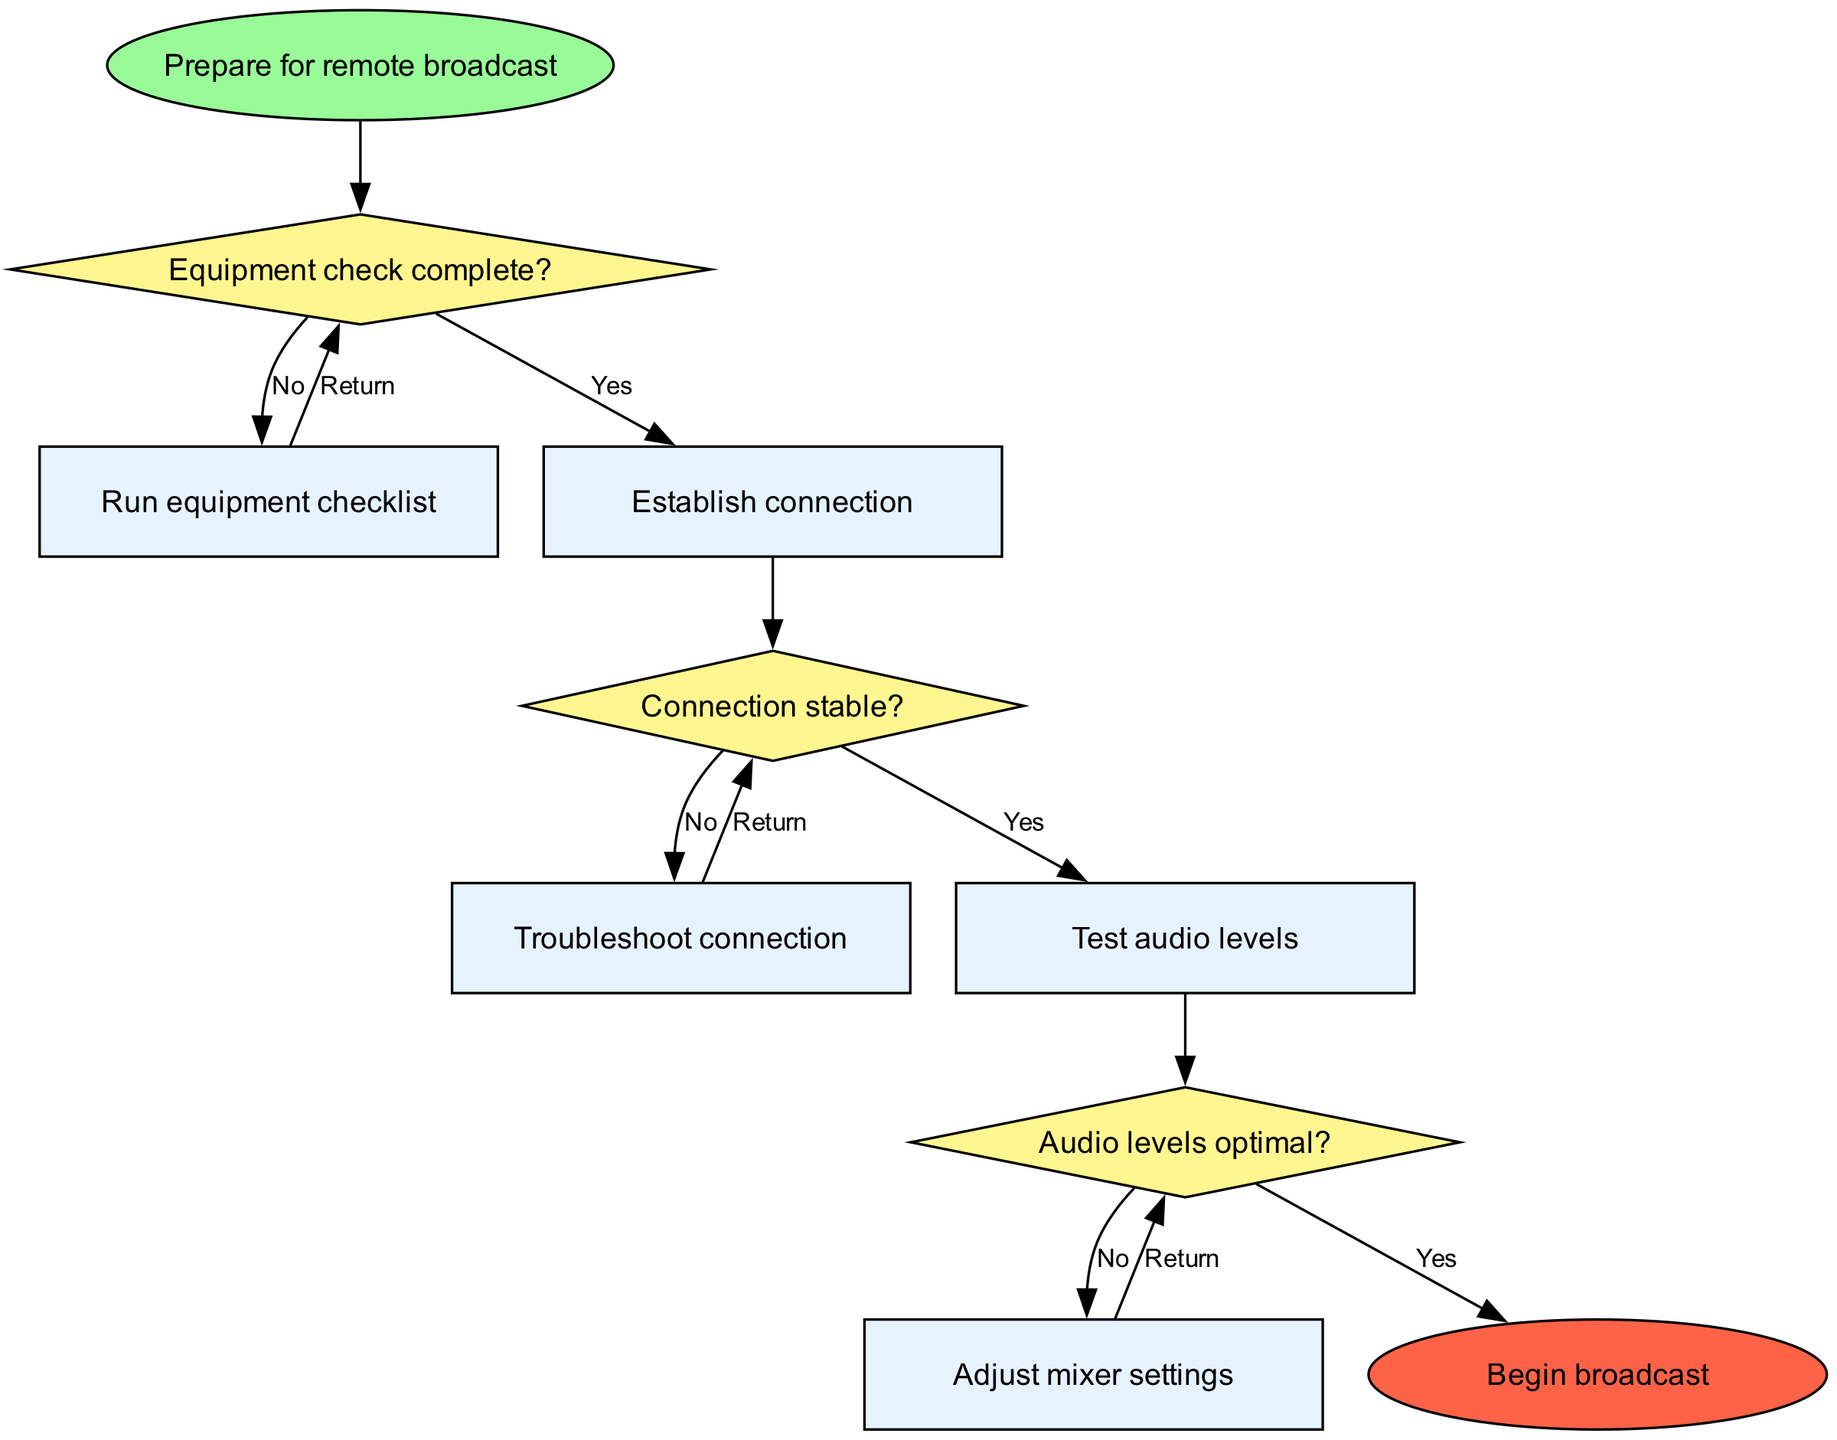What is the starting point of the flow chart? The flow chart begins with the node labeled "Prepare for remote broadcast," which indicates the initial step in the process.
Answer: Prepare for remote broadcast How many decision nodes are present in the diagram? The diagram includes three decision nodes, each representing a question related to the equipment setup and connection stability.
Answer: 3 What is the first action taken if the equipment check is not complete? If the equipment check is not completed, the flow diagram indicates to "Run equipment checklist," which is the process to ensure all equipment is ready.
Answer: Run equipment checklist What happens after establishing a connection? After establishing a connection, the next step as per the flow chart is to "Test audio levels," which verifies if the audio quality is acceptable for broadcasting.
Answer: Test audio levels If the audio levels are not optimal, what is the next step? If the audio levels are judged to be not optimal, the flow chart directs to "Adjust mixer settings," which is an action taken to modify the sound levels appropriately.
Answer: Adjust mixer settings What is the final output of the flow chart? The end goal of the flow chart, as indicated in the final node, is to "Begin broadcast," signifying that all prior steps must be completed before broadcasting starts.
Answer: Begin broadcast What are the possible outcomes after the connection stability check? After checking connection stability, there are two possible outcomes: if stable, proceed to "Test audio levels"; if not stable, the next step is "Troubleshoot connection."
Answer: Test audio levels or Troubleshoot connection What should be done if the audio levels are optimal? If the audio levels are found to be optimal, the flow chart indicates to "Begin broadcast" as the next step, completing the preparation phase.
Answer: Begin broadcast 